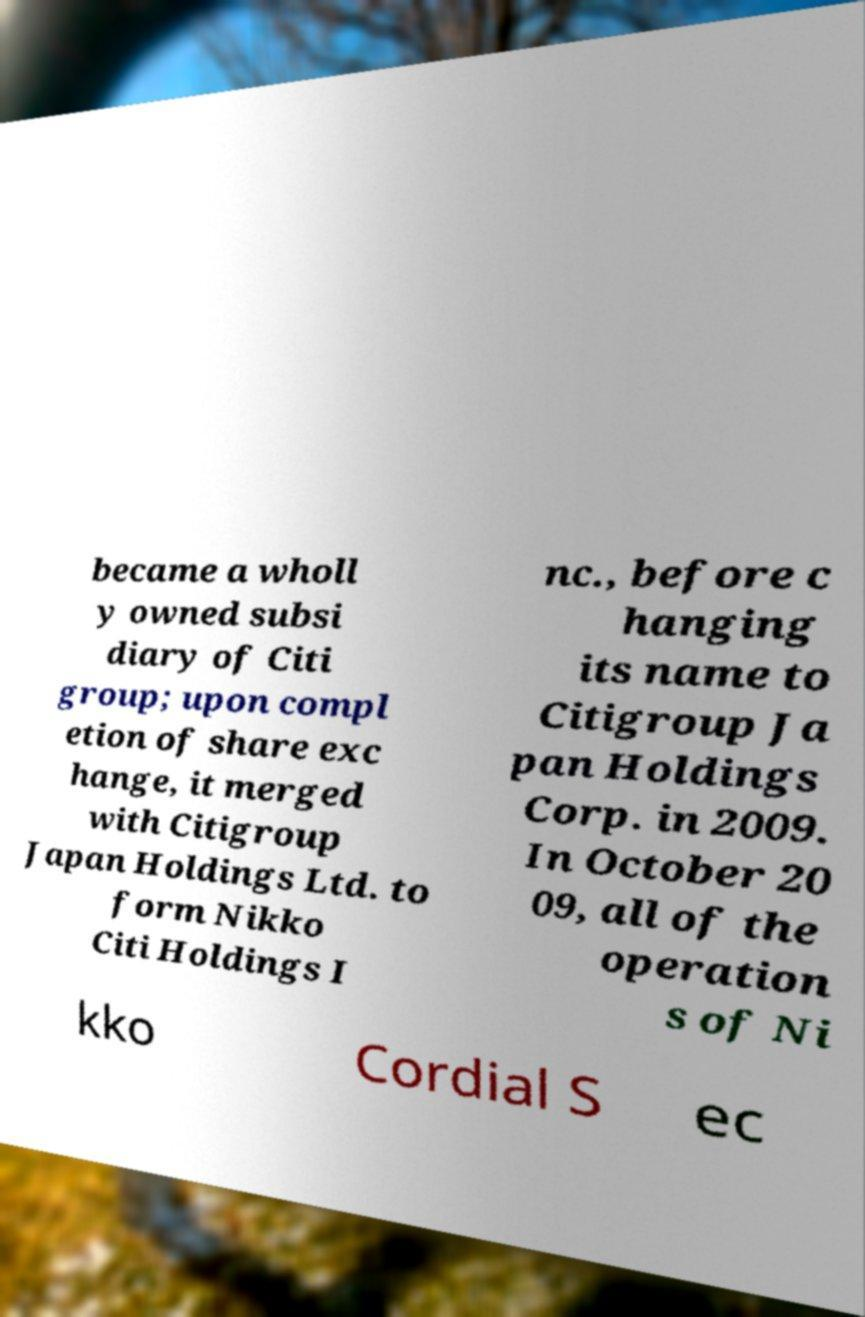There's text embedded in this image that I need extracted. Can you transcribe it verbatim? became a wholl y owned subsi diary of Citi group; upon compl etion of share exc hange, it merged with Citigroup Japan Holdings Ltd. to form Nikko Citi Holdings I nc., before c hanging its name to Citigroup Ja pan Holdings Corp. in 2009. In October 20 09, all of the operation s of Ni kko Cordial S ec 